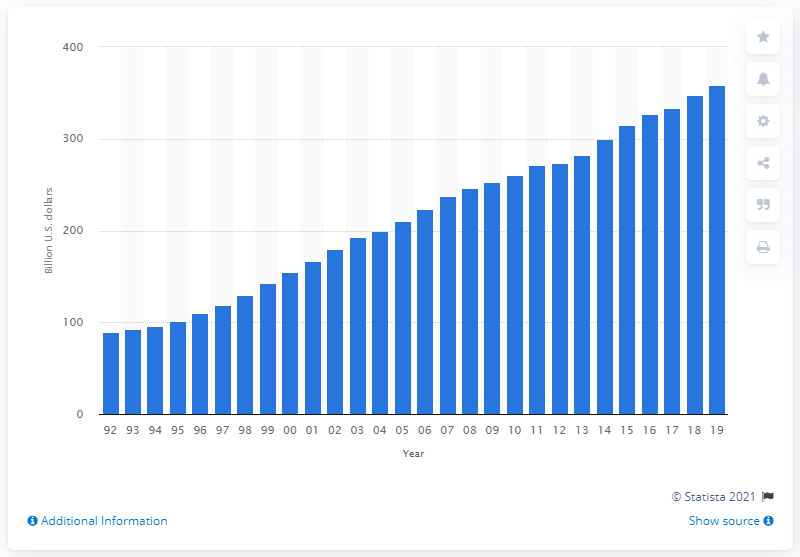List a handful of essential elements in this visual. In the United States in 2018, sales at health and personal care stores totaled approximately 347.45 million dollars. 